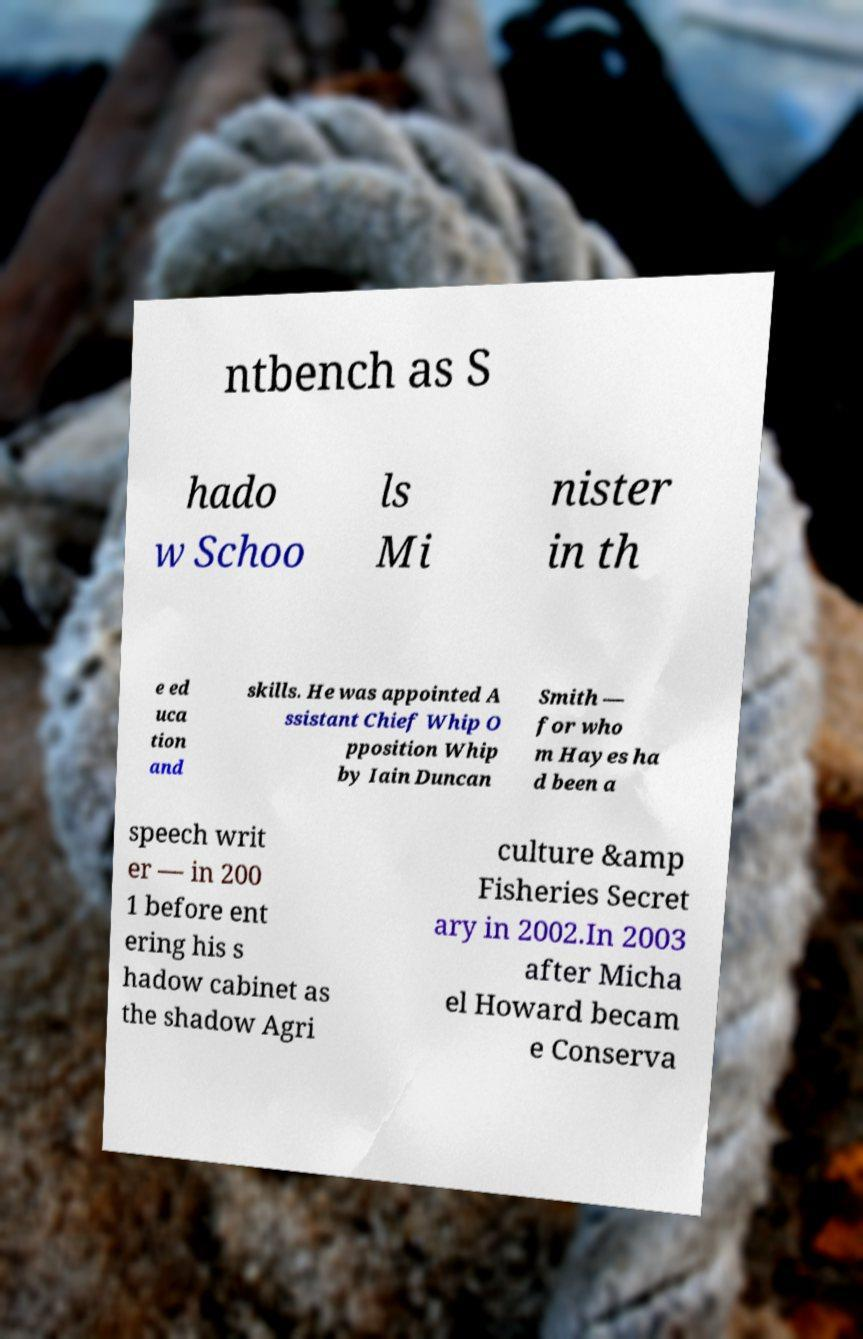For documentation purposes, I need the text within this image transcribed. Could you provide that? ntbench as S hado w Schoo ls Mi nister in th e ed uca tion and skills. He was appointed A ssistant Chief Whip O pposition Whip by Iain Duncan Smith — for who m Hayes ha d been a speech writ er — in 200 1 before ent ering his s hadow cabinet as the shadow Agri culture &amp Fisheries Secret ary in 2002.In 2003 after Micha el Howard becam e Conserva 